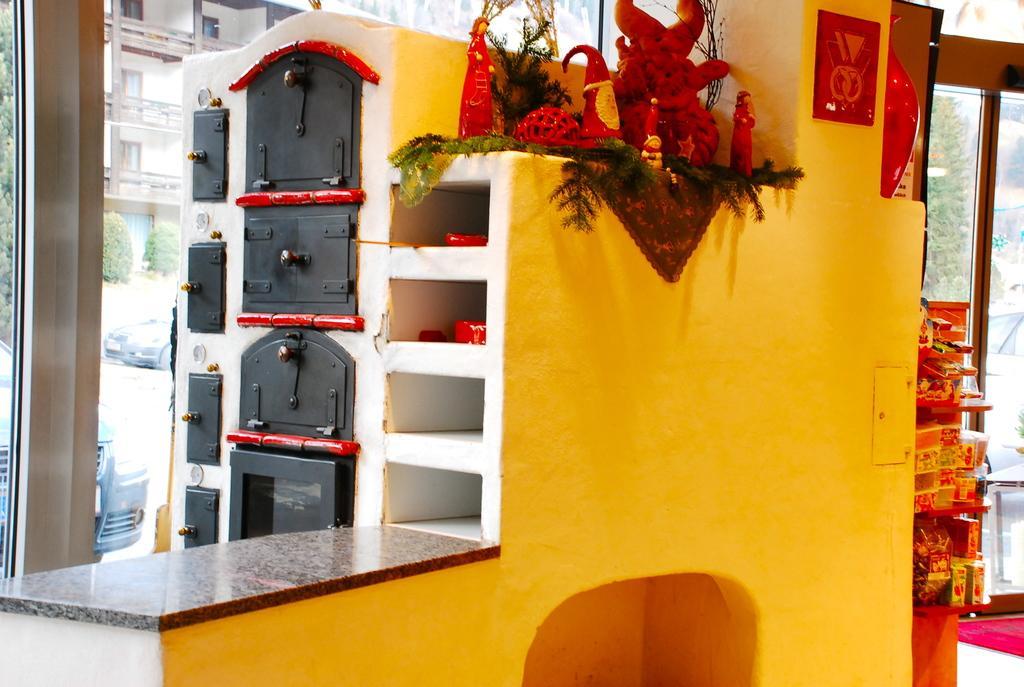Could you give a brief overview of what you see in this image? In this picture it looks like a toy house in the middle, on the left side I can see a glass wall. There are vehicles, trees, buildings in the background. 